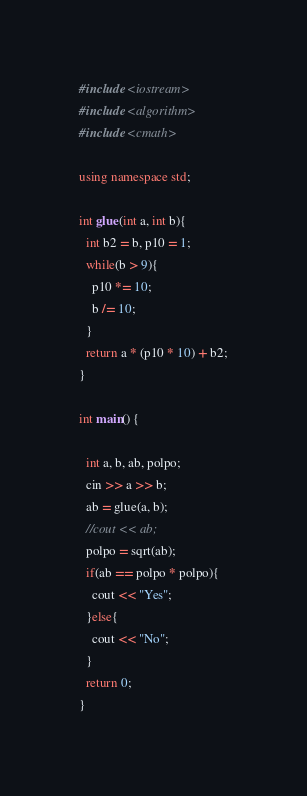<code> <loc_0><loc_0><loc_500><loc_500><_C++_>#include <iostream>
#include <algorithm>
#include <cmath>

using namespace std;

int glue(int a, int b){
  int b2 = b, p10 = 1;
  while(b > 9){
    p10 *= 10;
    b /= 10;
  }
  return a * (p10 * 10) + b2;
}

int main() {

  int a, b, ab, polpo;
  cin >> a >> b;
  ab = glue(a, b);
  //cout << ab;
  polpo = sqrt(ab);
  if(ab == polpo * polpo){
    cout << "Yes";
  }else{
    cout << "No";
  }
  return 0;
}
</code> 